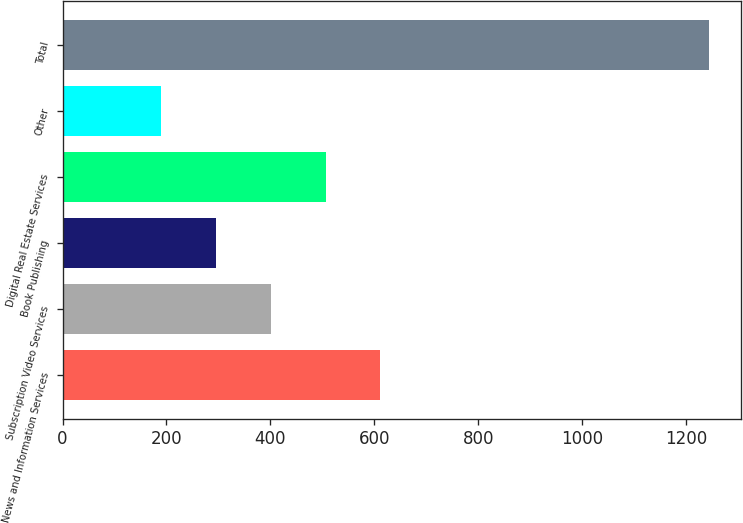Convert chart to OTSL. <chart><loc_0><loc_0><loc_500><loc_500><bar_chart><fcel>News and Information Services<fcel>Subscription Video Services<fcel>Book Publishing<fcel>Digital Real Estate Services<fcel>Other<fcel>Total<nl><fcel>611.6<fcel>400.8<fcel>295.4<fcel>506.2<fcel>190<fcel>1244<nl></chart> 